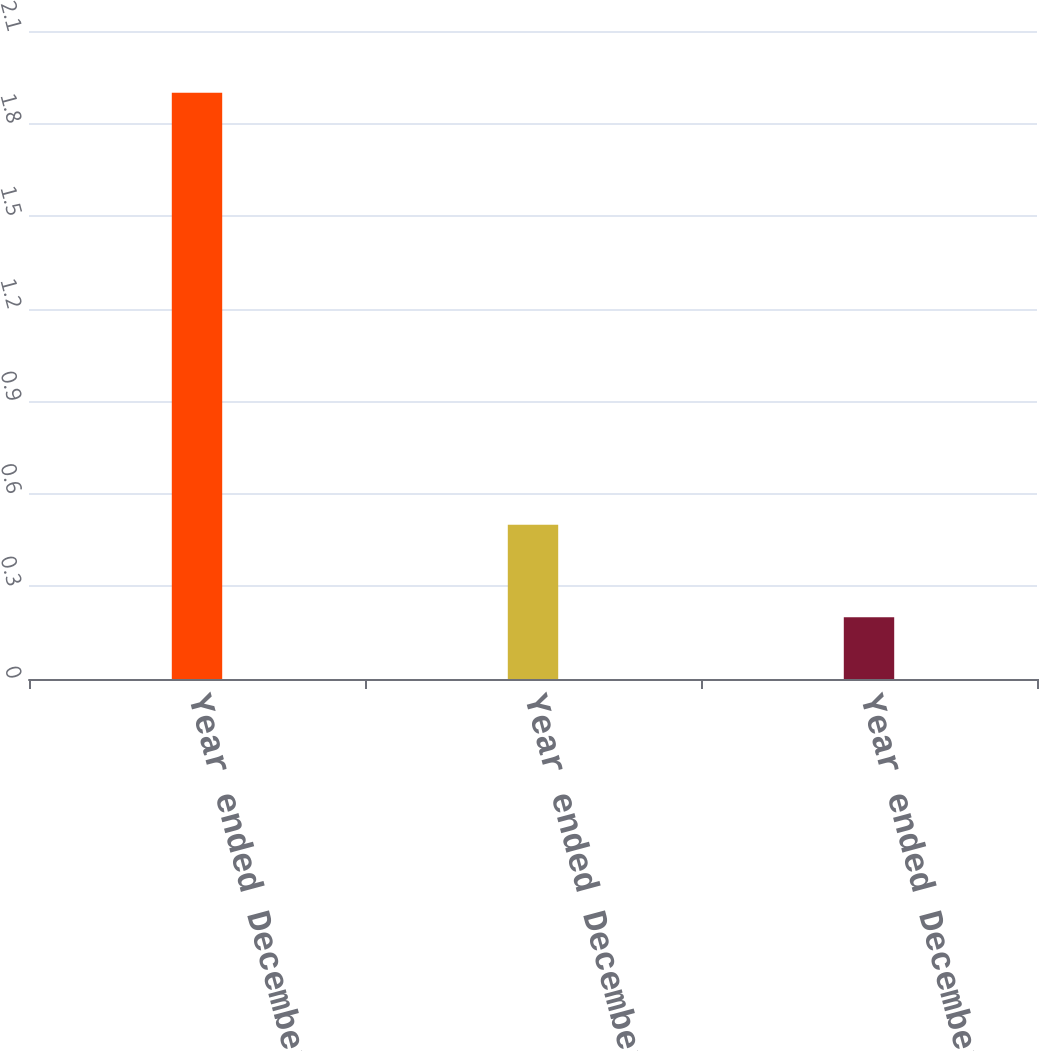Convert chart. <chart><loc_0><loc_0><loc_500><loc_500><bar_chart><fcel>Year ended December 31 2010<fcel>Year ended December 31 2009<fcel>Year ended December 31 2008<nl><fcel>1.9<fcel>0.5<fcel>0.2<nl></chart> 